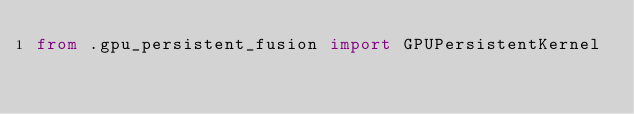Convert code to text. <code><loc_0><loc_0><loc_500><loc_500><_Python_>from .gpu_persistent_fusion import GPUPersistentKernel</code> 